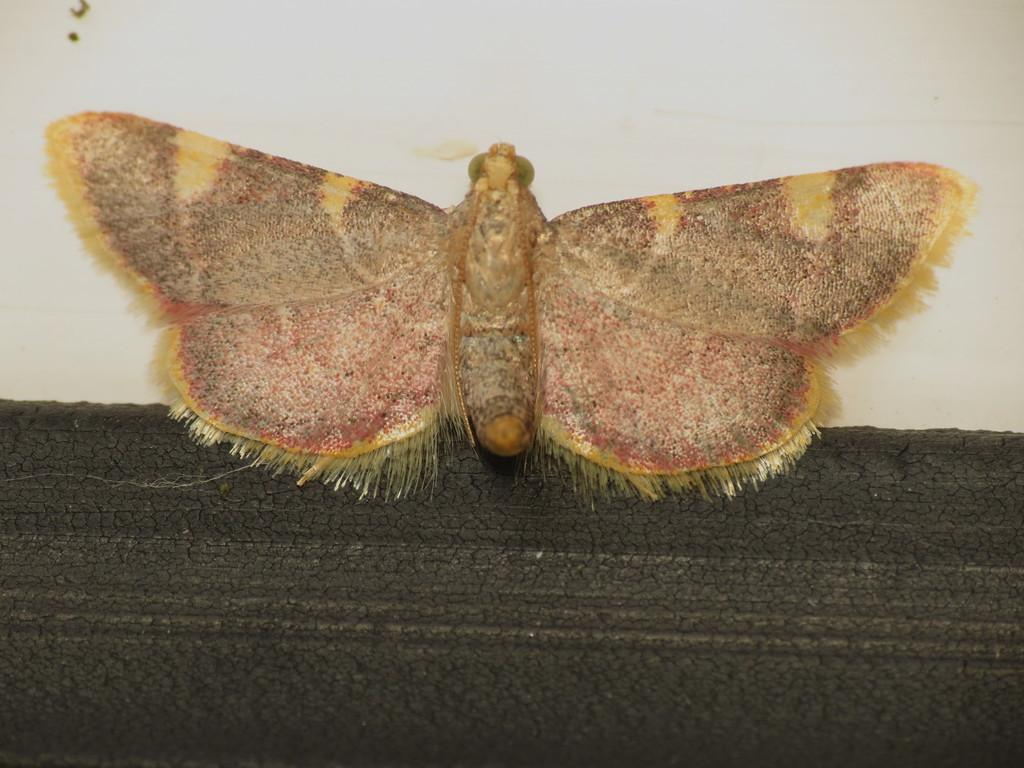What is present on the wall in the image? There is an insect on the wall in the image. What can be seen at the bottom of the image? There is a black object at the bottom of the image. How many birds are in the flock that is flying over the insect in the image? There is no flock of birds present in the image; it only features an insect on the wall and a black object at the bottom. What is the nature of the love between the insect and the black object in the image? There is no indication of love or any relationship between the insect and the black object in the image. 